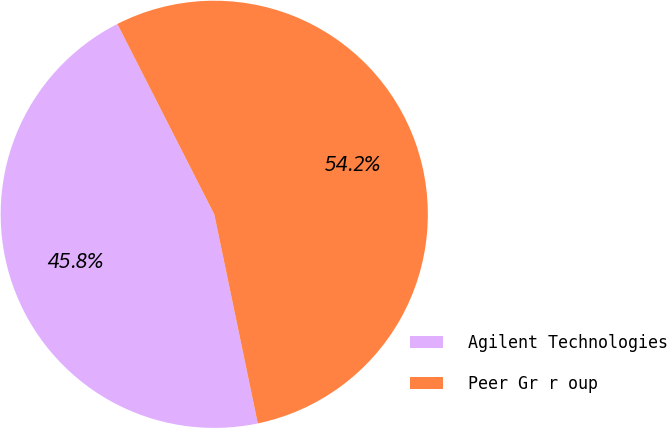Convert chart to OTSL. <chart><loc_0><loc_0><loc_500><loc_500><pie_chart><fcel>Agilent Technologies<fcel>Peer Gr r oup<nl><fcel>45.77%<fcel>54.23%<nl></chart> 